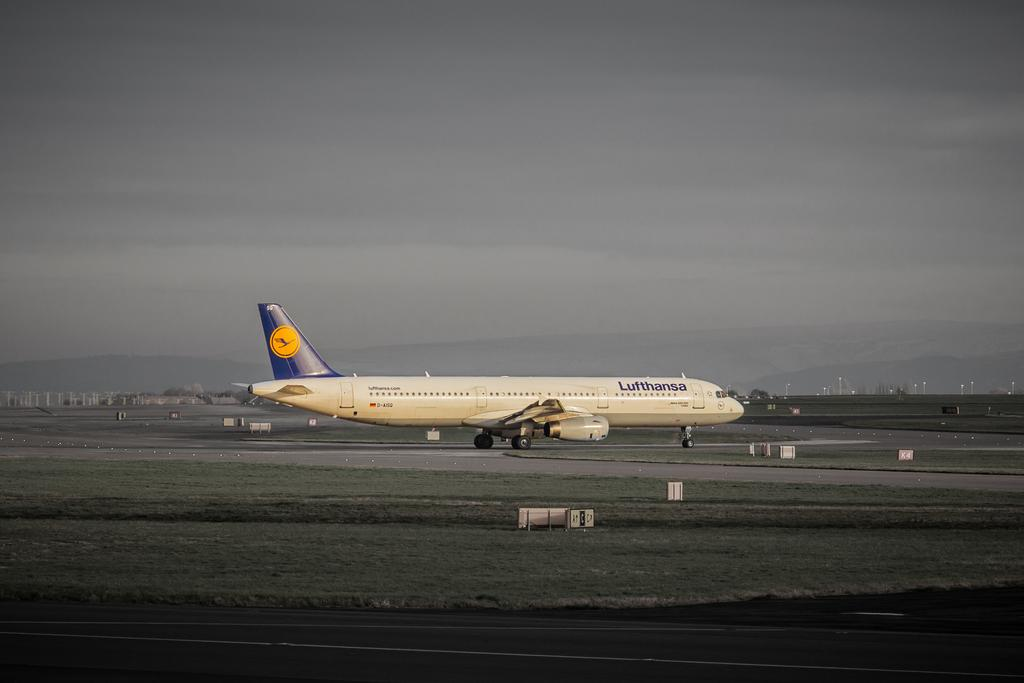What is the main subject of the picture? The main subject of the picture is an airplane. What else can be seen in the picture besides the airplane? There is a road, grass, boards, poles, and the sky visible in the picture. Can you describe the road in the picture? The road is a part of the image, but no specific details about its condition or direction are provided. What is the color of the sky in the background of the picture? The color of the sky is not mentioned in the provided facts, so it cannot be determined from the image. Can you tell me how many people are laughing while pasting the boards in the image? There is no mention of people laughing or pasting boards in the image. The image features an airplane, a road, grass, boards, poles, and the sky, but no human activity related to pasting or laughter is depicted. 